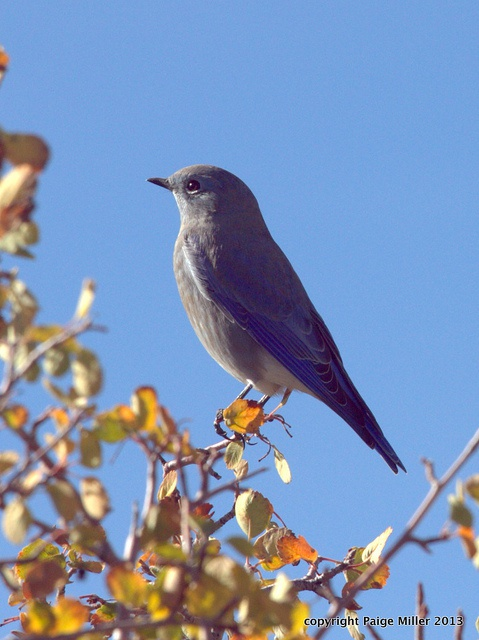Describe the objects in this image and their specific colors. I can see a bird in lightblue, navy, gray, purple, and darkgray tones in this image. 